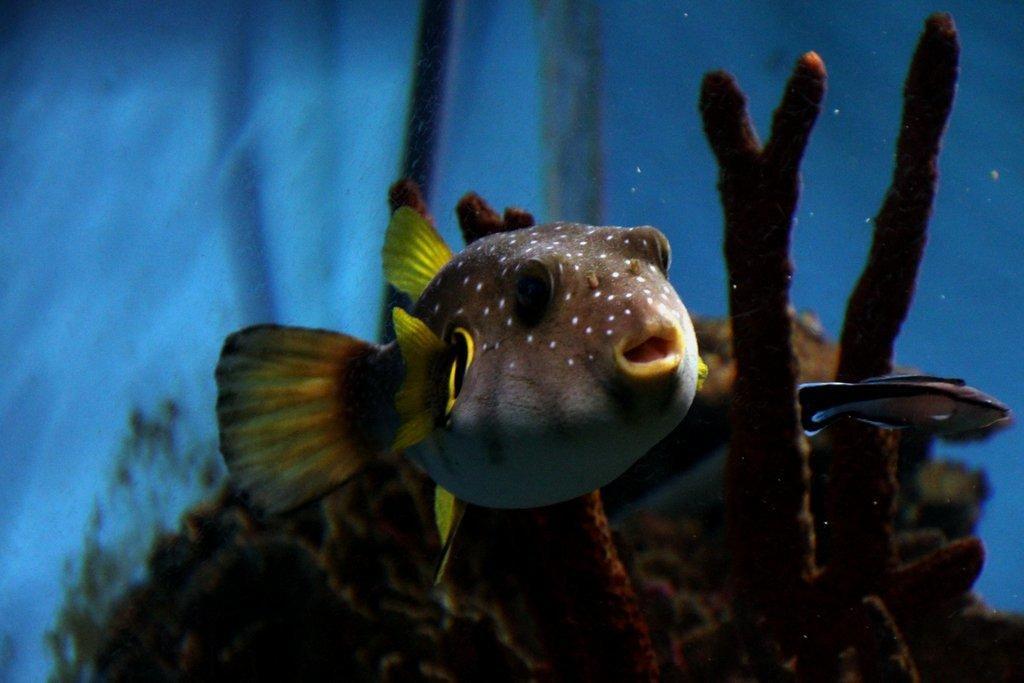Please provide a concise description of this image. In the image we can see there are fishes swimming in the water. 